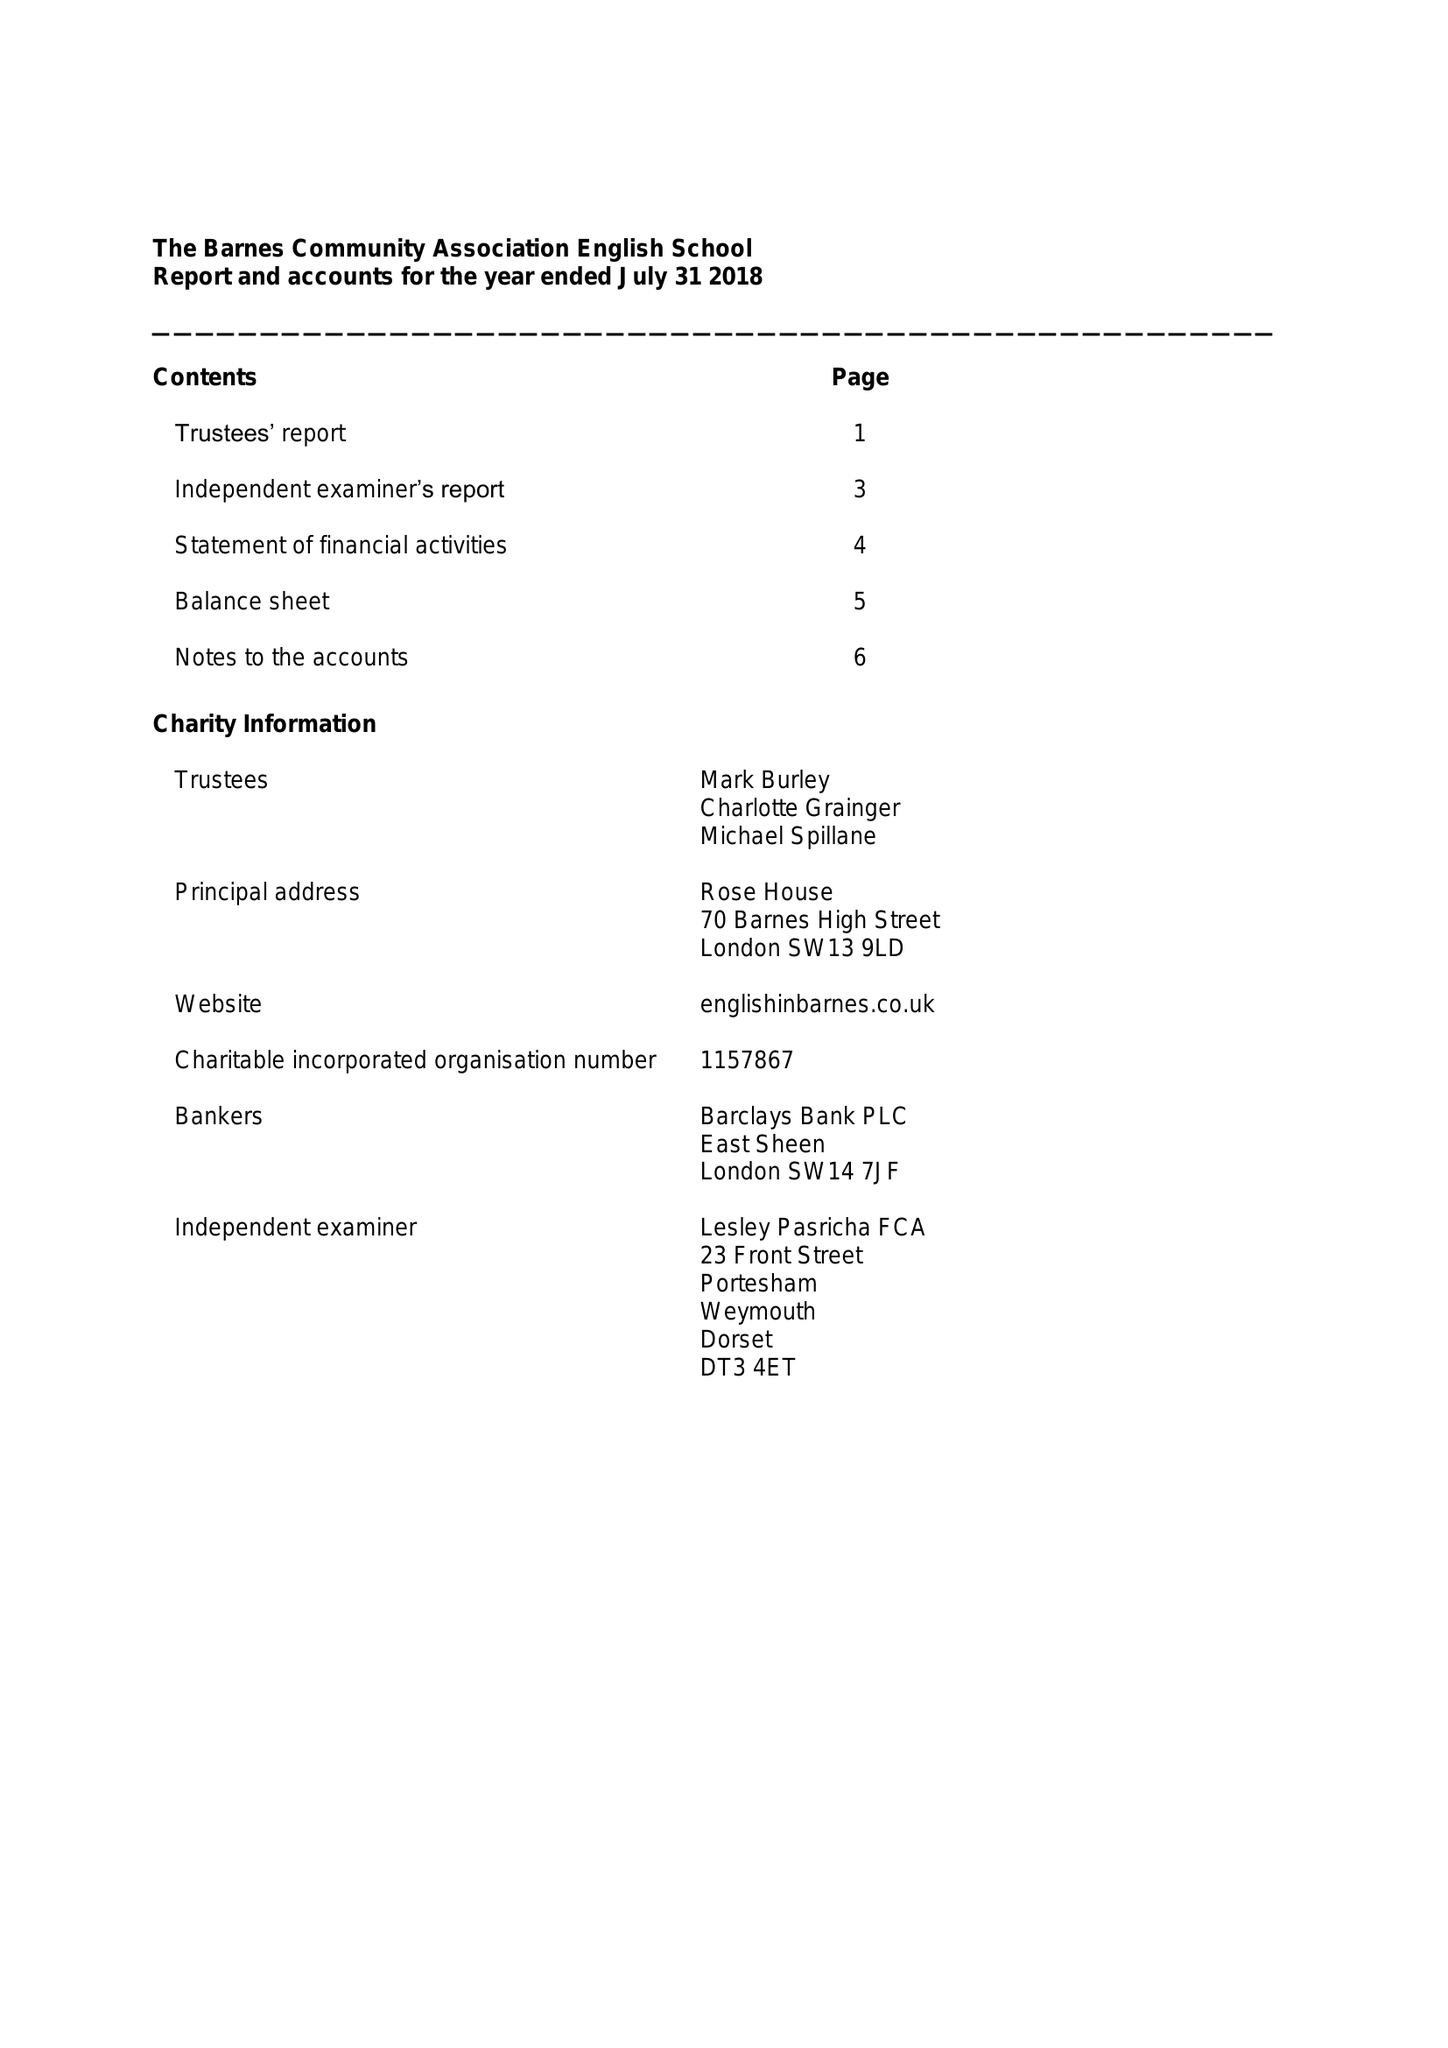What is the value for the address__post_town?
Answer the question using a single word or phrase. LONDON 